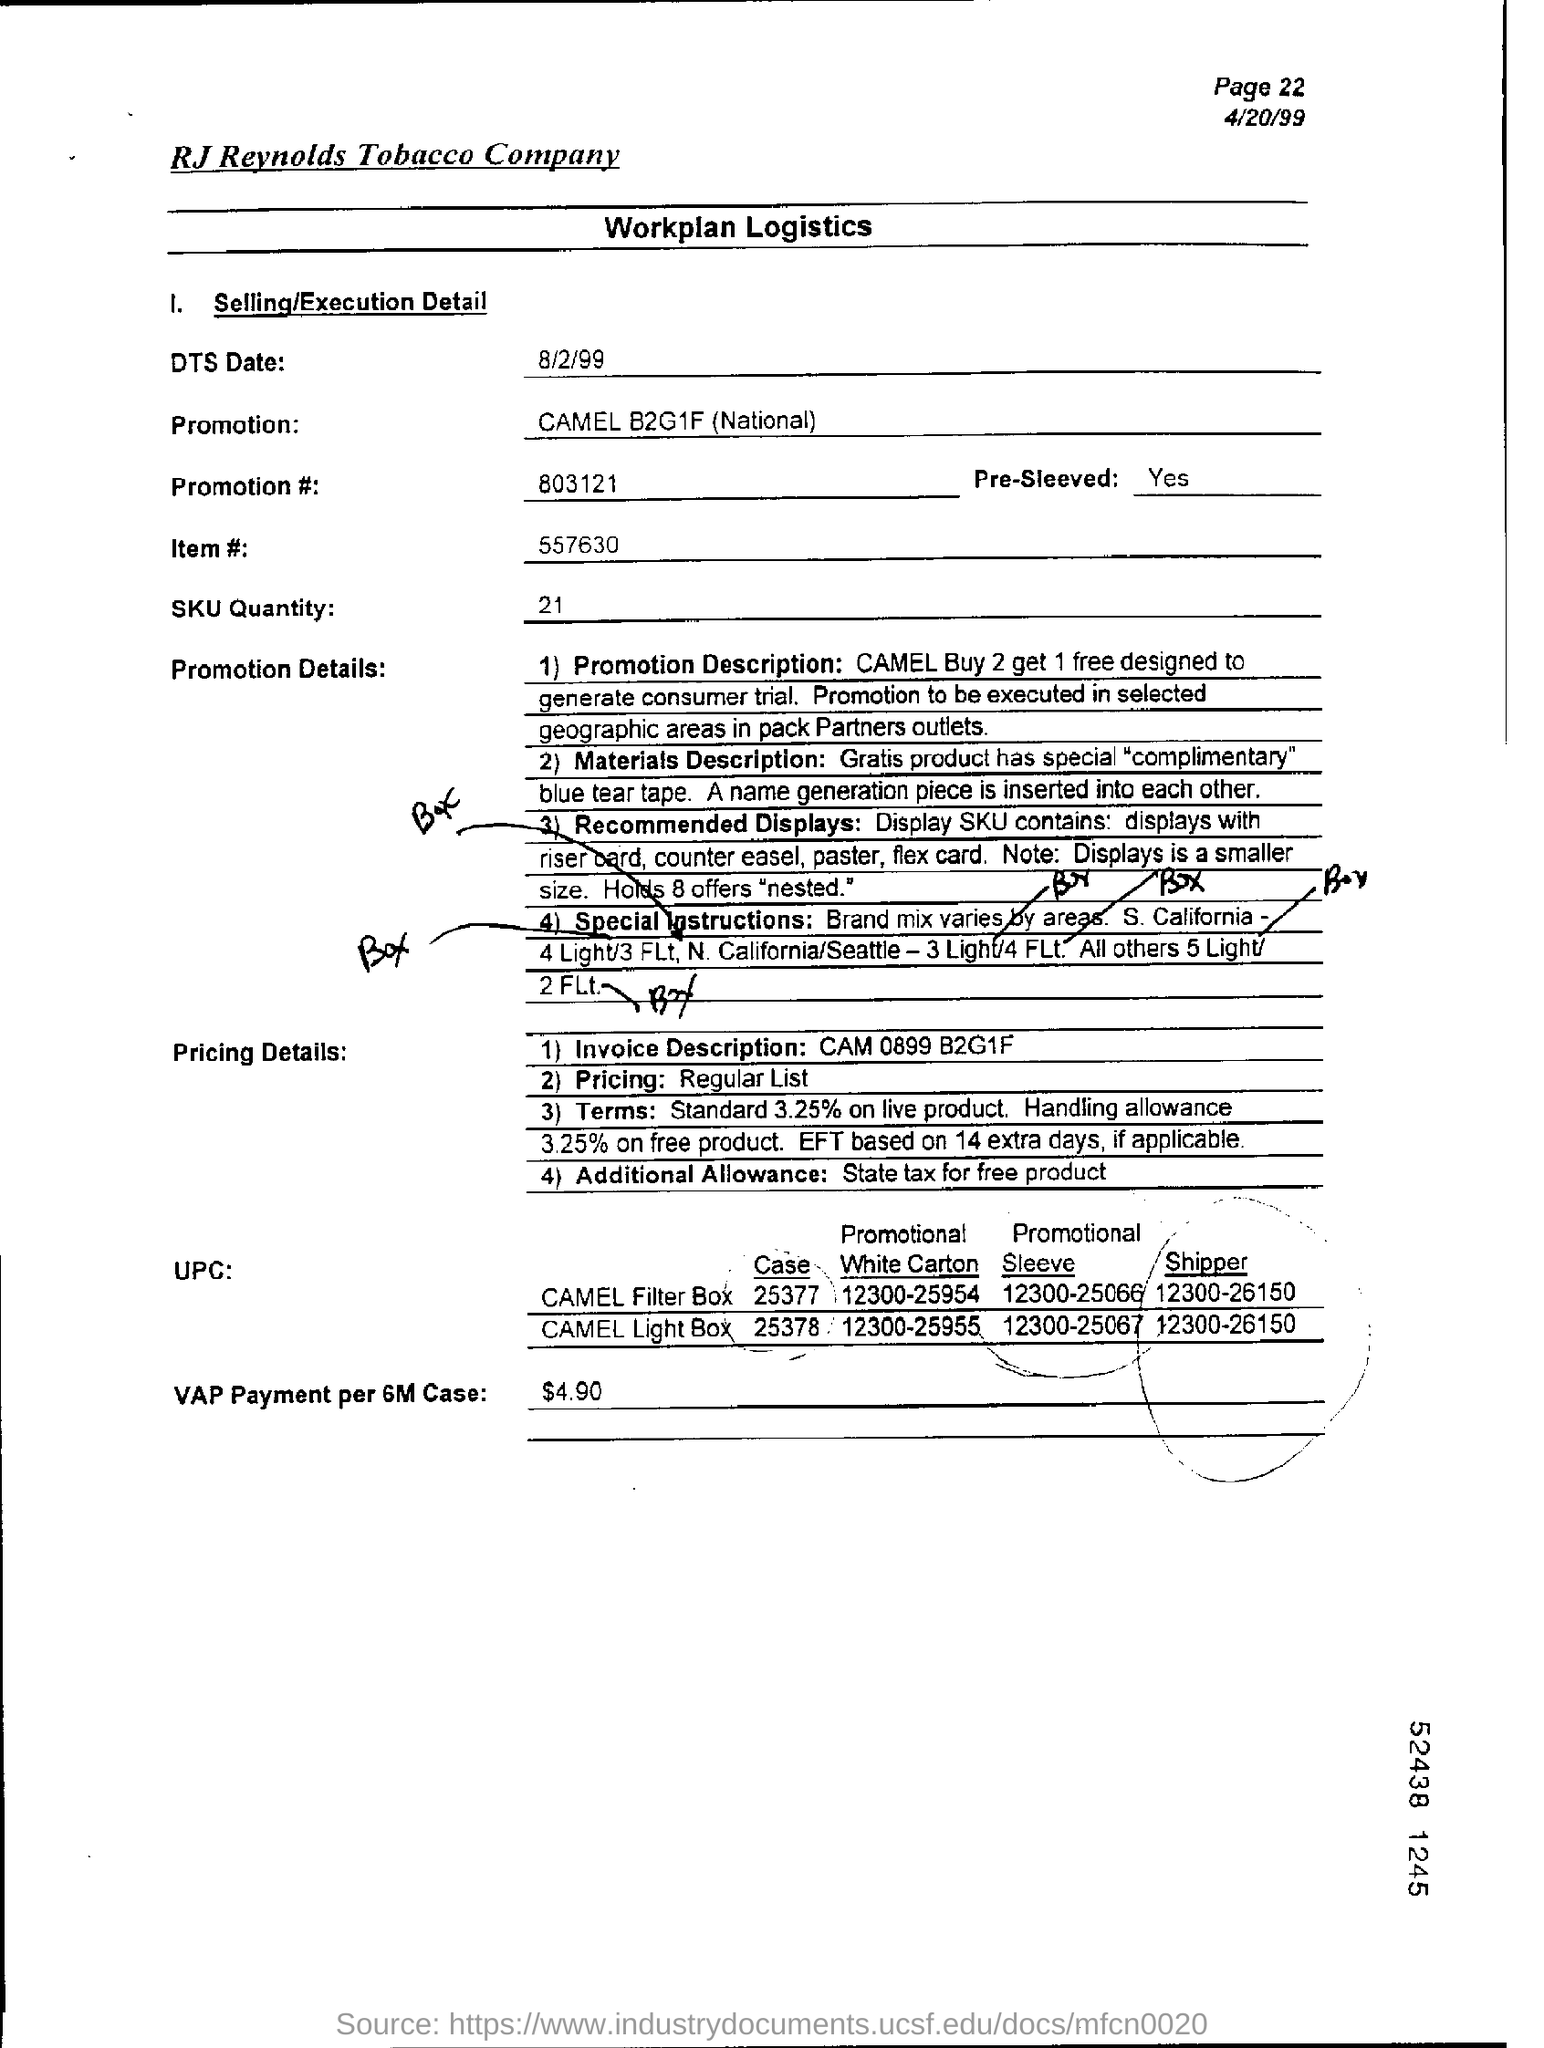Identify some key points in this picture. The promotion number given under "Selling/Execution Detail" is 803121. The "Invoice Description" under "Pricing Details" refers to the item "CAM 0899 B2G1F" and means that it is a product that is being sold at a discounted price when purchased in bulk, with two items being sold for the price of one. The "VAP Payment per 6M Case" is $4.90. The ITEM number given is 557630... The page number displayed at the top right corner of the page is referred to as the "page number" and can be used to identify the current page of a document. Specifically, "Page 22" refers to the 22nd page of the document. 